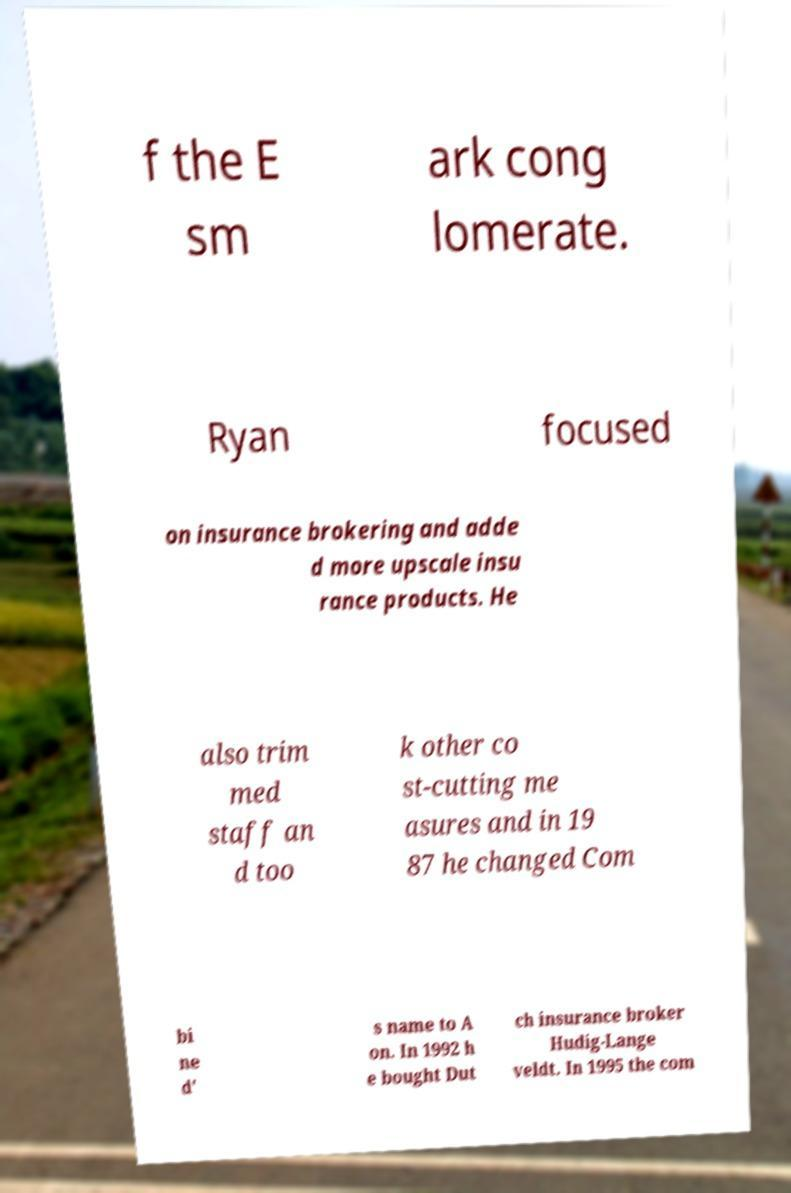There's text embedded in this image that I need extracted. Can you transcribe it verbatim? f the E sm ark cong lomerate. Ryan focused on insurance brokering and adde d more upscale insu rance products. He also trim med staff an d too k other co st-cutting me asures and in 19 87 he changed Com bi ne d' s name to A on. In 1992 h e bought Dut ch insurance broker Hudig-Lange veldt. In 1995 the com 